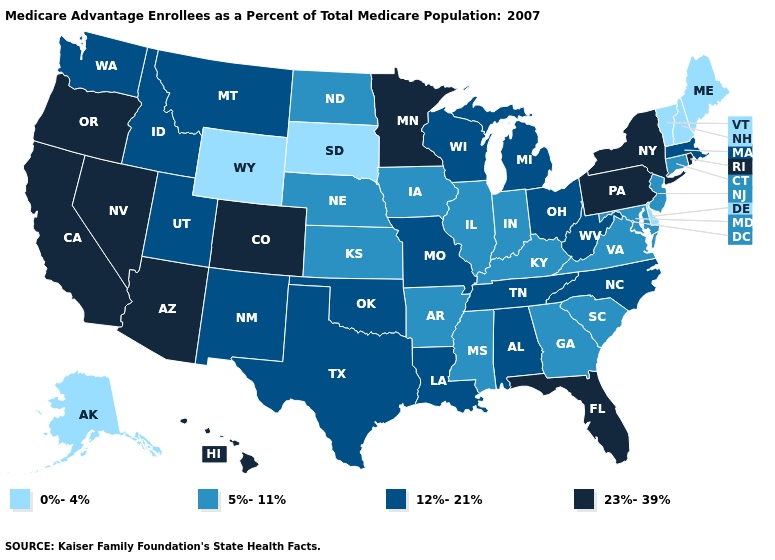What is the lowest value in the South?
Be succinct. 0%-4%. Which states have the highest value in the USA?
Keep it brief. Arizona, California, Colorado, Florida, Hawaii, Minnesota, Nevada, New York, Oregon, Pennsylvania, Rhode Island. What is the lowest value in the Northeast?
Be succinct. 0%-4%. Which states have the highest value in the USA?
Answer briefly. Arizona, California, Colorado, Florida, Hawaii, Minnesota, Nevada, New York, Oregon, Pennsylvania, Rhode Island. Which states have the lowest value in the USA?
Write a very short answer. Alaska, Delaware, Maine, New Hampshire, South Dakota, Vermont, Wyoming. Among the states that border South Carolina , does North Carolina have the lowest value?
Keep it brief. No. Is the legend a continuous bar?
Answer briefly. No. Among the states that border Virginia , does North Carolina have the lowest value?
Be succinct. No. Among the states that border Colorado , does Utah have the lowest value?
Write a very short answer. No. Which states have the highest value in the USA?
Answer briefly. Arizona, California, Colorado, Florida, Hawaii, Minnesota, Nevada, New York, Oregon, Pennsylvania, Rhode Island. What is the lowest value in states that border North Dakota?
Short answer required. 0%-4%. Does the map have missing data?
Short answer required. No. Name the states that have a value in the range 23%-39%?
Quick response, please. Arizona, California, Colorado, Florida, Hawaii, Minnesota, Nevada, New York, Oregon, Pennsylvania, Rhode Island. What is the lowest value in states that border Nevada?
Be succinct. 12%-21%. 